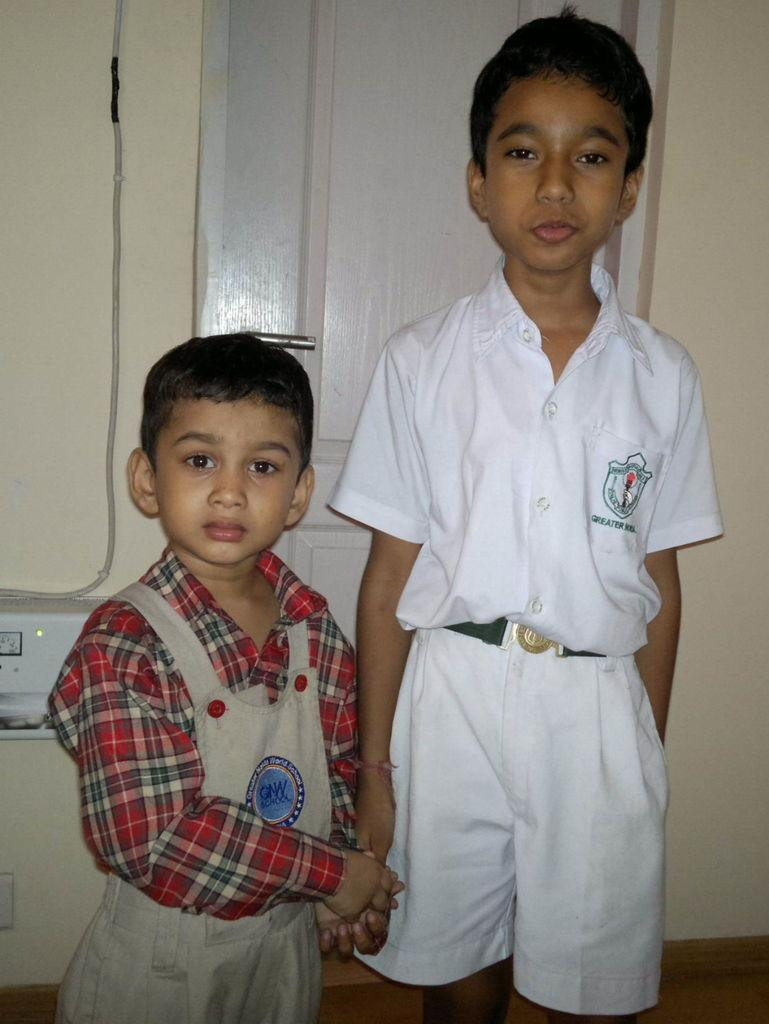How many boys are present in the image? There are two boys standing in the image. What is located behind the boys? There is a wall behind the boys. Can you describe any architectural features in the image? Yes, there is a door visible in the image. What type of object can be seen in the image that is related to electricity? There is an electrical device in the image. Is there any visible connection between the electrical device and a power source? Yes, there is a cable in the image that may be connected to the electrical device. What type of weather can be seen in the image? The image does not provide any information about the weather, as it focuses on the boys, wall, door, cable, and electrical device. 